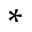Convert formula to latex. <formula><loc_0><loc_0><loc_500><loc_500>^ { \ast }</formula> 